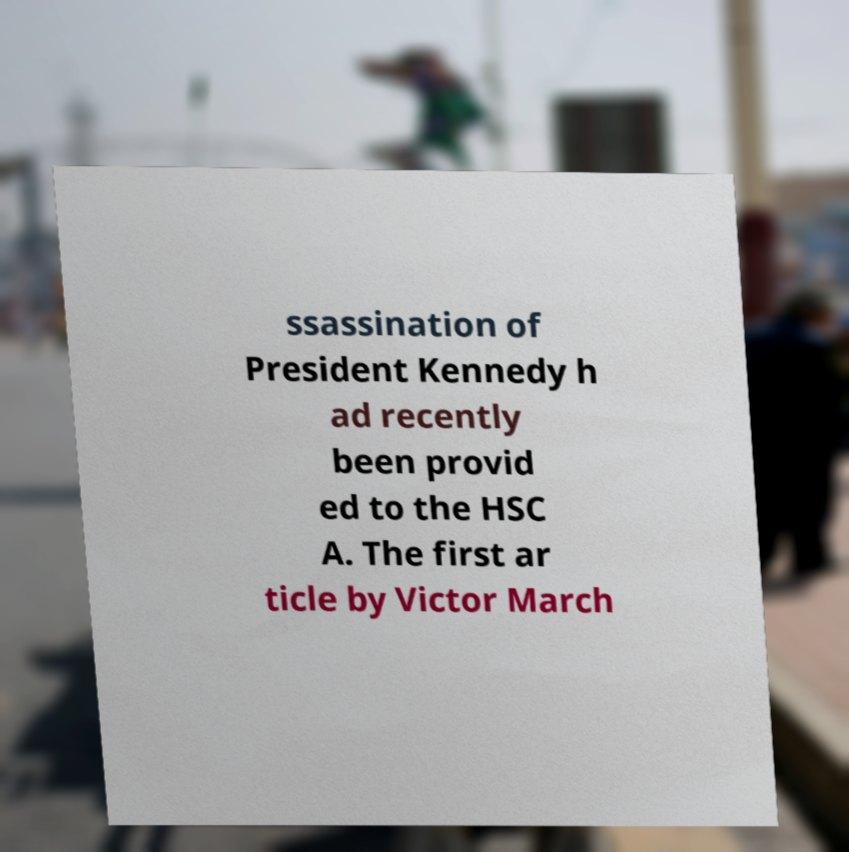Can you accurately transcribe the text from the provided image for me? ssassination of President Kennedy h ad recently been provid ed to the HSC A. The first ar ticle by Victor March 